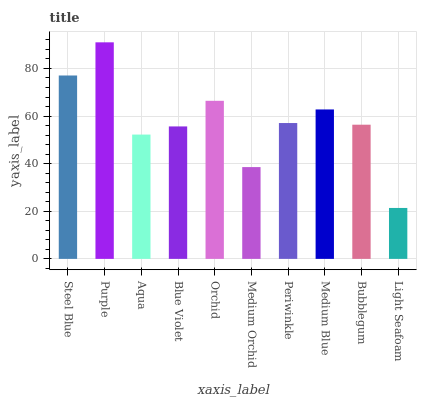Is Light Seafoam the minimum?
Answer yes or no. Yes. Is Purple the maximum?
Answer yes or no. Yes. Is Aqua the minimum?
Answer yes or no. No. Is Aqua the maximum?
Answer yes or no. No. Is Purple greater than Aqua?
Answer yes or no. Yes. Is Aqua less than Purple?
Answer yes or no. Yes. Is Aqua greater than Purple?
Answer yes or no. No. Is Purple less than Aqua?
Answer yes or no. No. Is Periwinkle the high median?
Answer yes or no. Yes. Is Bubblegum the low median?
Answer yes or no. Yes. Is Medium Blue the high median?
Answer yes or no. No. Is Medium Orchid the low median?
Answer yes or no. No. 